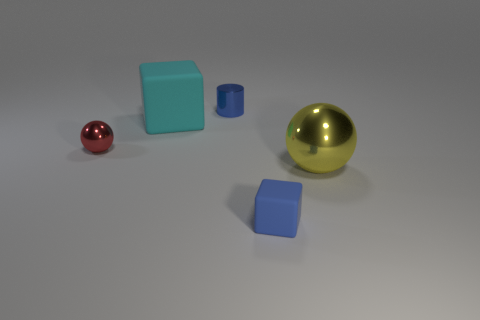Add 2 yellow blocks. How many objects exist? 7 Subtract all cylinders. How many objects are left? 4 Subtract 0 brown spheres. How many objects are left? 5 Subtract all yellow things. Subtract all red spheres. How many objects are left? 3 Add 5 yellow shiny spheres. How many yellow shiny spheres are left? 6 Add 5 big cyan rubber things. How many big cyan rubber things exist? 6 